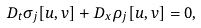Convert formula to latex. <formula><loc_0><loc_0><loc_500><loc_500>D _ { t } \sigma _ { j } [ u , v ] + D _ { x } \rho _ { j } [ u , v ] = 0 ,</formula> 